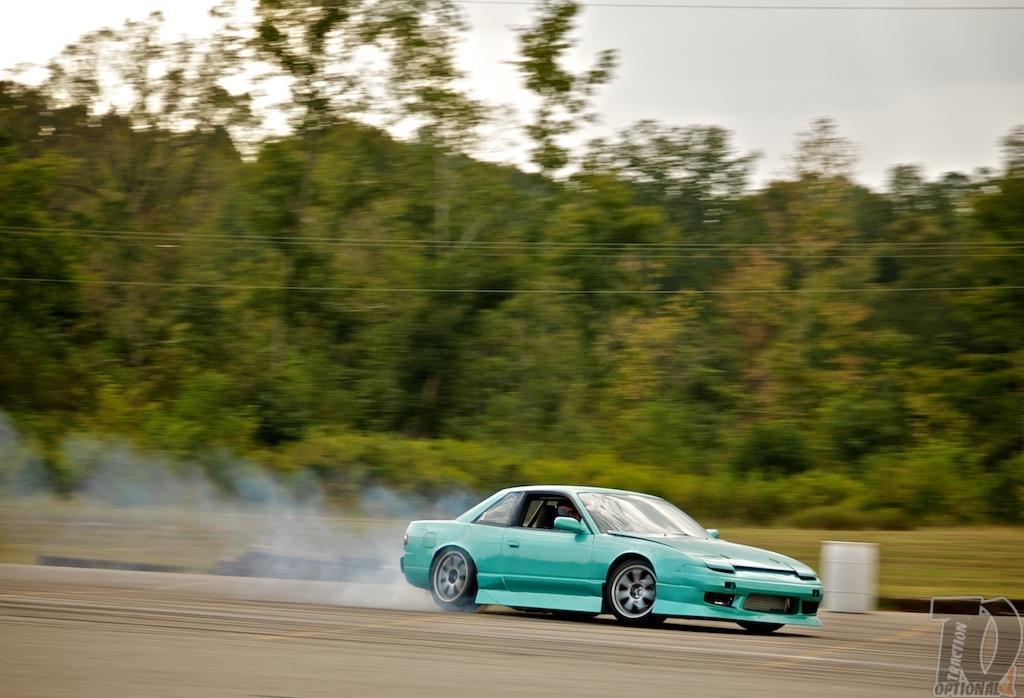Please provide a concise description of this image. In this image I can see the vehicle in green color and I can also see the person sitting in the vehicle. In the background I can see few trees in green color and the sky is in white color. 